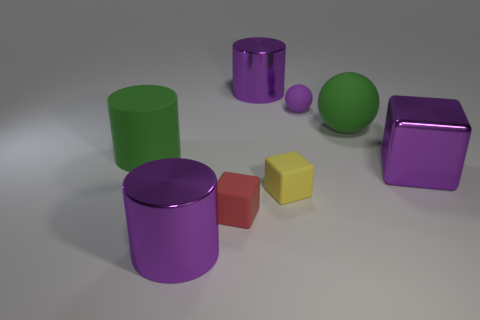Are there the same number of green rubber balls that are right of the big purple shiny block and tiny matte objects in front of the green cylinder?
Your answer should be very brief. No. There is a purple thing that is right of the yellow cube and behind the green rubber cylinder; what is its material?
Provide a succinct answer. Rubber. There is a matte block in front of the yellow rubber object that is right of the purple shiny cylinder that is behind the big ball; what is its size?
Make the answer very short. Small. There is a small thing in front of the small yellow rubber block; does it have the same shape as the small yellow matte object?
Offer a very short reply. Yes. Is there any other thing that has the same color as the large matte cylinder?
Offer a terse response. Yes. Do the red matte block and the purple shiny cube have the same size?
Provide a succinct answer. No. How many things are the same size as the yellow rubber cube?
Your answer should be compact. 2. What is the shape of the object that is the same color as the large ball?
Your answer should be very brief. Cylinder. Do the big green sphere right of the tiny ball and the big purple object that is in front of the small yellow matte block have the same material?
Provide a succinct answer. No. The shiny cube is what color?
Provide a short and direct response. Purple. 